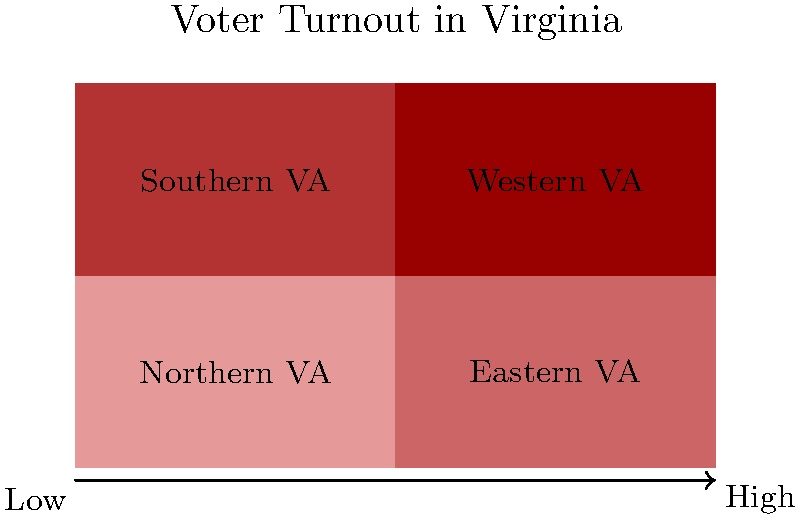Based on the map of Virginia's voter turnout, which region shows the highest level of civic engagement, and what factors might contribute to this trend in the context of social activism and feminism? To answer this question, let's analyze the map step-by-step:

1. The map shows four regions of Virginia: Northern VA, Eastern VA, Southern VA, and Western VA.
2. The color gradient indicates voter turnout, with darker shades of red representing higher turnout.
3. Northern Virginia (top-left) has the darkest shade, indicating the highest voter turnout.

Factors contributing to this trend in the context of social activism and feminism:

1. Urban concentration: Northern Virginia is more urbanized, often correlating with higher education levels and increased political awareness.
2. Proximity to Washington D.C.: Being close to the nation's capital may increase political engagement and awareness of national issues.
3. Demographic diversity: Urban areas tend to have more diverse populations, potentially leading to increased activism for social justice and equality.
4. Higher income and education levels: These factors often correlate with increased civic engagement and feminist awareness.
5. Presence of advocacy groups: Urban areas typically have more organizations focused on social activism and feminism, encouraging political participation.
6. Access to information: Urban areas often have better access to diverse media sources, potentially increasing awareness of political and social issues.

The combination of these factors likely contributes to Northern Virginia's higher voter turnout, reflecting increased civic engagement in the context of social activism and feminism.
Answer: Northern Virginia; urban concentration, proximity to D.C., diversity, education, advocacy groups, and information access. 